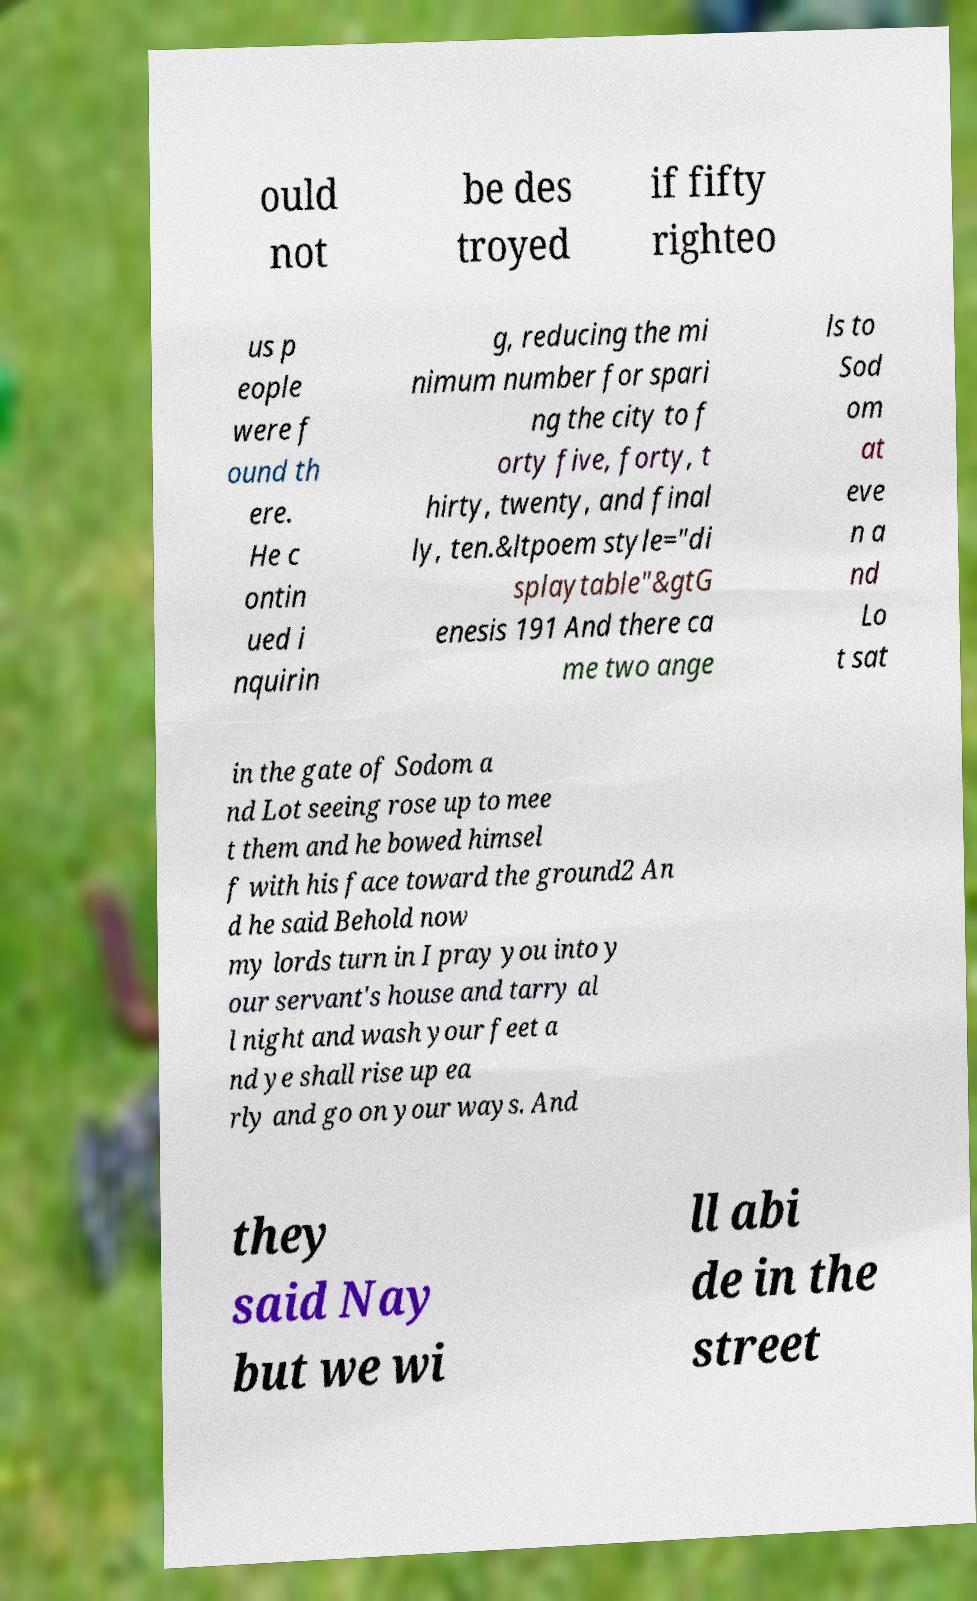Can you accurately transcribe the text from the provided image for me? ould not be des troyed if fifty righteo us p eople were f ound th ere. He c ontin ued i nquirin g, reducing the mi nimum number for spari ng the city to f orty five, forty, t hirty, twenty, and final ly, ten.&ltpoem style="di splaytable"&gtG enesis 191 And there ca me two ange ls to Sod om at eve n a nd Lo t sat in the gate of Sodom a nd Lot seeing rose up to mee t them and he bowed himsel f with his face toward the ground2 An d he said Behold now my lords turn in I pray you into y our servant's house and tarry al l night and wash your feet a nd ye shall rise up ea rly and go on your ways. And they said Nay but we wi ll abi de in the street 